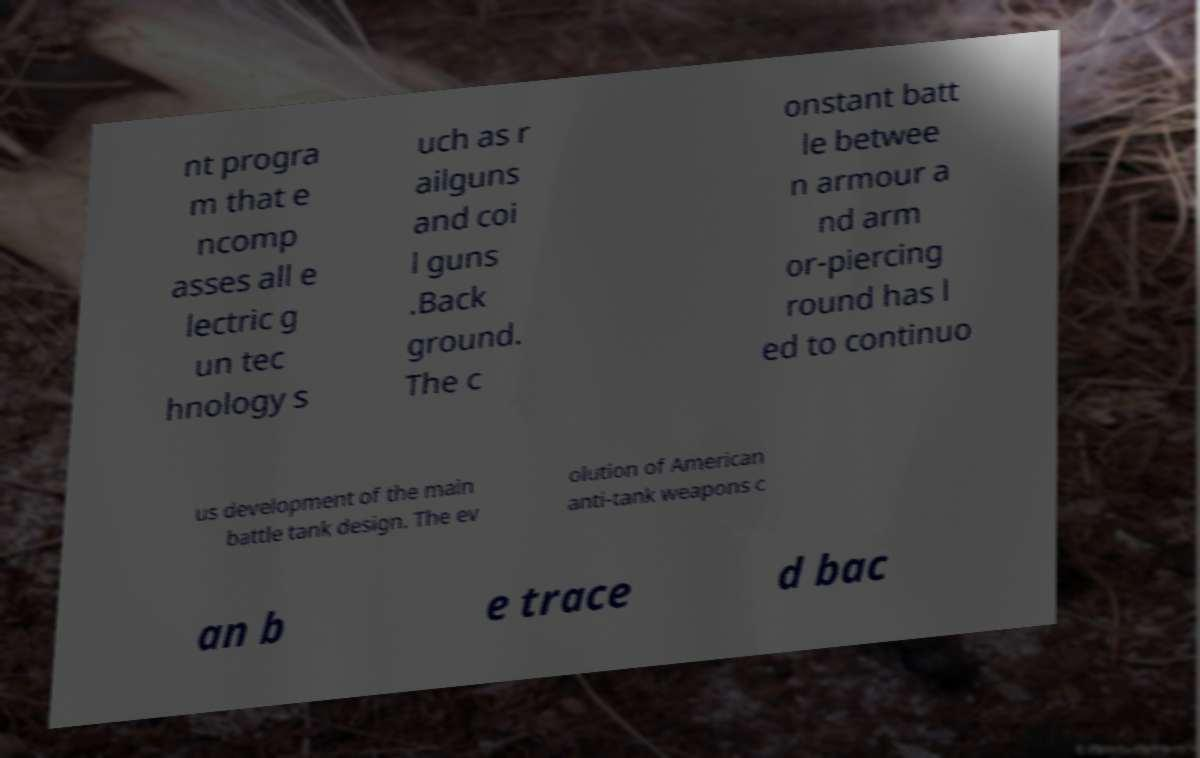Can you accurately transcribe the text from the provided image for me? nt progra m that e ncomp asses all e lectric g un tec hnology s uch as r ailguns and coi l guns .Back ground. The c onstant batt le betwee n armour a nd arm or-piercing round has l ed to continuo us development of the main battle tank design. The ev olution of American anti-tank weapons c an b e trace d bac 